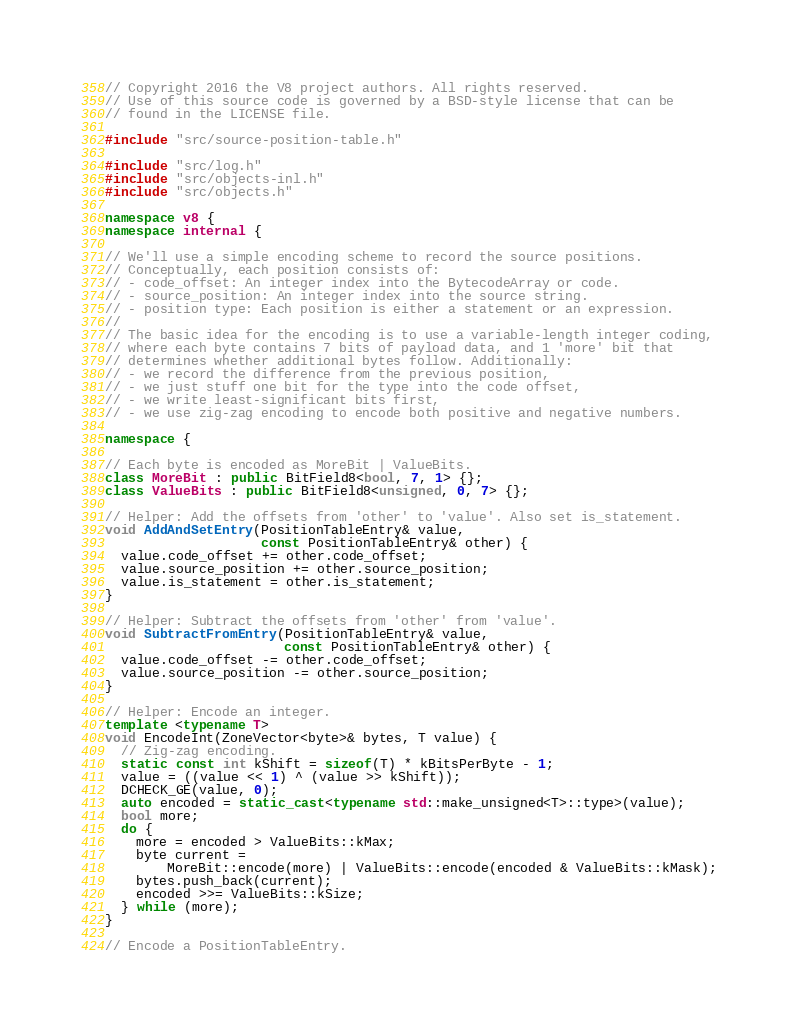Convert code to text. <code><loc_0><loc_0><loc_500><loc_500><_C++_>// Copyright 2016 the V8 project authors. All rights reserved.
// Use of this source code is governed by a BSD-style license that can be
// found in the LICENSE file.

#include "src/source-position-table.h"

#include "src/log.h"
#include "src/objects-inl.h"
#include "src/objects.h"

namespace v8 {
namespace internal {

// We'll use a simple encoding scheme to record the source positions.
// Conceptually, each position consists of:
// - code_offset: An integer index into the BytecodeArray or code.
// - source_position: An integer index into the source string.
// - position type: Each position is either a statement or an expression.
//
// The basic idea for the encoding is to use a variable-length integer coding,
// where each byte contains 7 bits of payload data, and 1 'more' bit that
// determines whether additional bytes follow. Additionally:
// - we record the difference from the previous position,
// - we just stuff one bit for the type into the code offset,
// - we write least-significant bits first,
// - we use zig-zag encoding to encode both positive and negative numbers.

namespace {

// Each byte is encoded as MoreBit | ValueBits.
class MoreBit : public BitField8<bool, 7, 1> {};
class ValueBits : public BitField8<unsigned, 0, 7> {};

// Helper: Add the offsets from 'other' to 'value'. Also set is_statement.
void AddAndSetEntry(PositionTableEntry& value,
                    const PositionTableEntry& other) {
  value.code_offset += other.code_offset;
  value.source_position += other.source_position;
  value.is_statement = other.is_statement;
}

// Helper: Subtract the offsets from 'other' from 'value'.
void SubtractFromEntry(PositionTableEntry& value,
                       const PositionTableEntry& other) {
  value.code_offset -= other.code_offset;
  value.source_position -= other.source_position;
}

// Helper: Encode an integer.
template <typename T>
void EncodeInt(ZoneVector<byte>& bytes, T value) {
  // Zig-zag encoding.
  static const int kShift = sizeof(T) * kBitsPerByte - 1;
  value = ((value << 1) ^ (value >> kShift));
  DCHECK_GE(value, 0);
  auto encoded = static_cast<typename std::make_unsigned<T>::type>(value);
  bool more;
  do {
    more = encoded > ValueBits::kMax;
    byte current =
        MoreBit::encode(more) | ValueBits::encode(encoded & ValueBits::kMask);
    bytes.push_back(current);
    encoded >>= ValueBits::kSize;
  } while (more);
}

// Encode a PositionTableEntry.</code> 